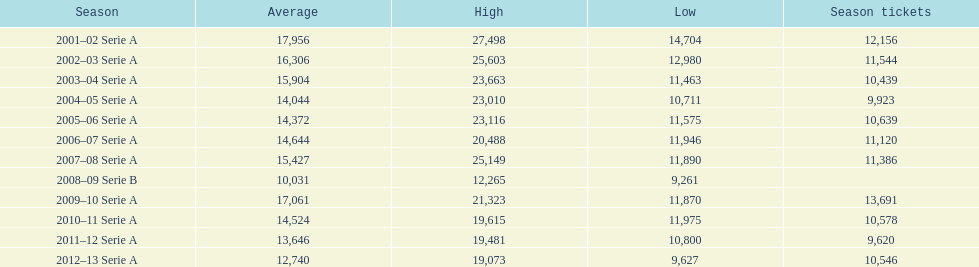When were all of the seasons? 2001–02 Serie A, 2002–03 Serie A, 2003–04 Serie A, 2004–05 Serie A, 2005–06 Serie A, 2006–07 Serie A, 2007–08 Serie A, 2008–09 Serie B, 2009–10 Serie A, 2010–11 Serie A, 2011–12 Serie A, 2012–13 Serie A. How many tickets were sold? 12,156, 11,544, 10,439, 9,923, 10,639, 11,120, 11,386, , 13,691, 10,578, 9,620, 10,546. What about just during the 2007 season? 11,386. 